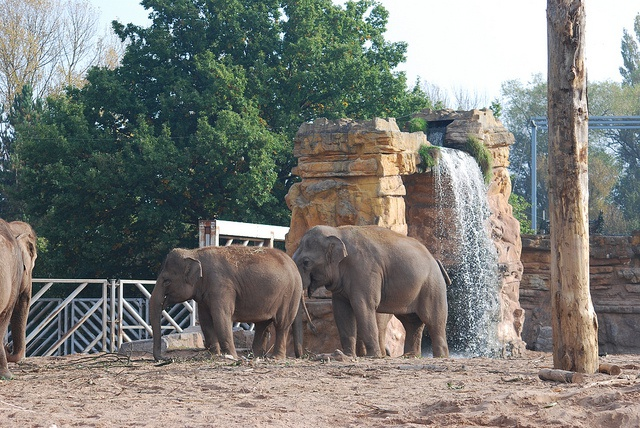Describe the objects in this image and their specific colors. I can see elephant in lavender, gray, darkgray, and black tones, elephant in lavender, gray, and black tones, and elephant in lavender, darkgray, tan, gray, and black tones in this image. 